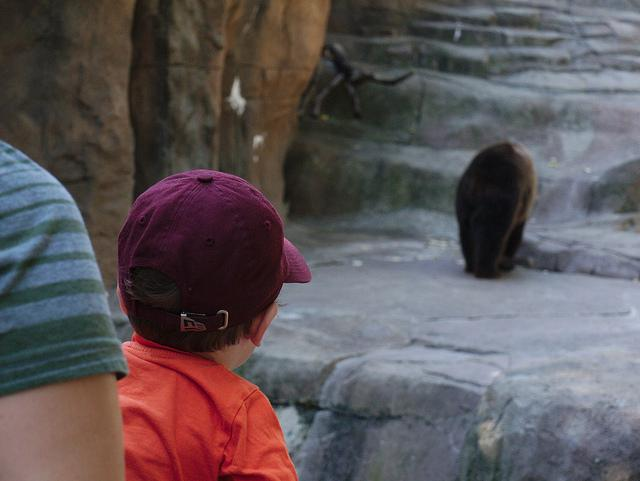Where is the boy visiting? Please explain your reasoning. zoo. He is at the zoo looking at the animals. 